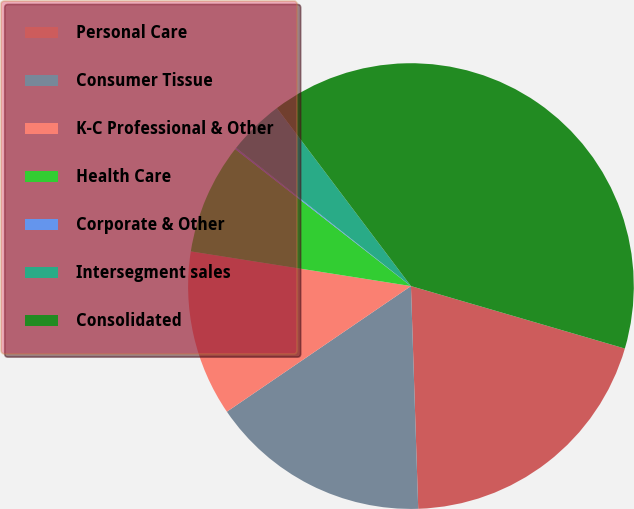Convert chart. <chart><loc_0><loc_0><loc_500><loc_500><pie_chart><fcel>Personal Care<fcel>Consumer Tissue<fcel>K-C Professional & Other<fcel>Health Care<fcel>Corporate & Other<fcel>Intersegment sales<fcel>Consolidated<nl><fcel>19.96%<fcel>15.99%<fcel>12.02%<fcel>8.05%<fcel>0.11%<fcel>4.08%<fcel>39.8%<nl></chart> 